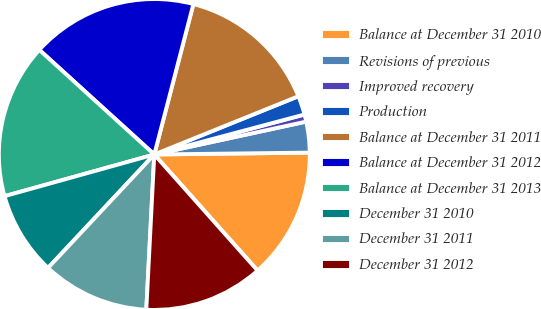<chart> <loc_0><loc_0><loc_500><loc_500><pie_chart><fcel>Balance at December 31 2010<fcel>Revisions of previous<fcel>Improved recovery<fcel>Production<fcel>Balance at December 31 2011<fcel>Balance at December 31 2012<fcel>Balance at December 31 2013<fcel>December 31 2010<fcel>December 31 2011<fcel>December 31 2012<nl><fcel>13.62%<fcel>3.2%<fcel>0.75%<fcel>1.97%<fcel>14.84%<fcel>17.3%<fcel>16.07%<fcel>8.7%<fcel>11.16%<fcel>12.39%<nl></chart> 